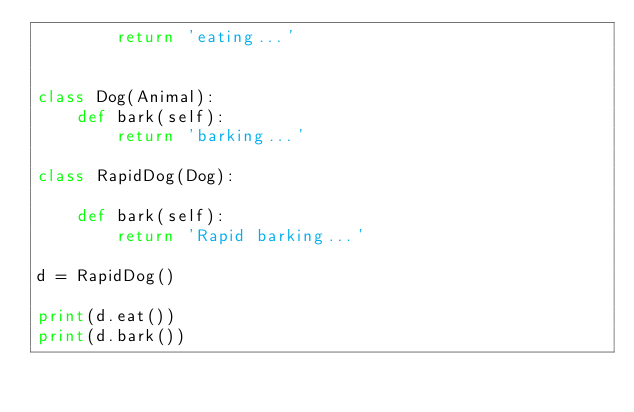<code> <loc_0><loc_0><loc_500><loc_500><_Python_>        return 'eating...'


class Dog(Animal):
    def bark(self):
        return 'barking...'

class RapidDog(Dog):

    def bark(self):
        return 'Rapid barking...'

d = RapidDog()

print(d.eat())
print(d.bark())
</code> 